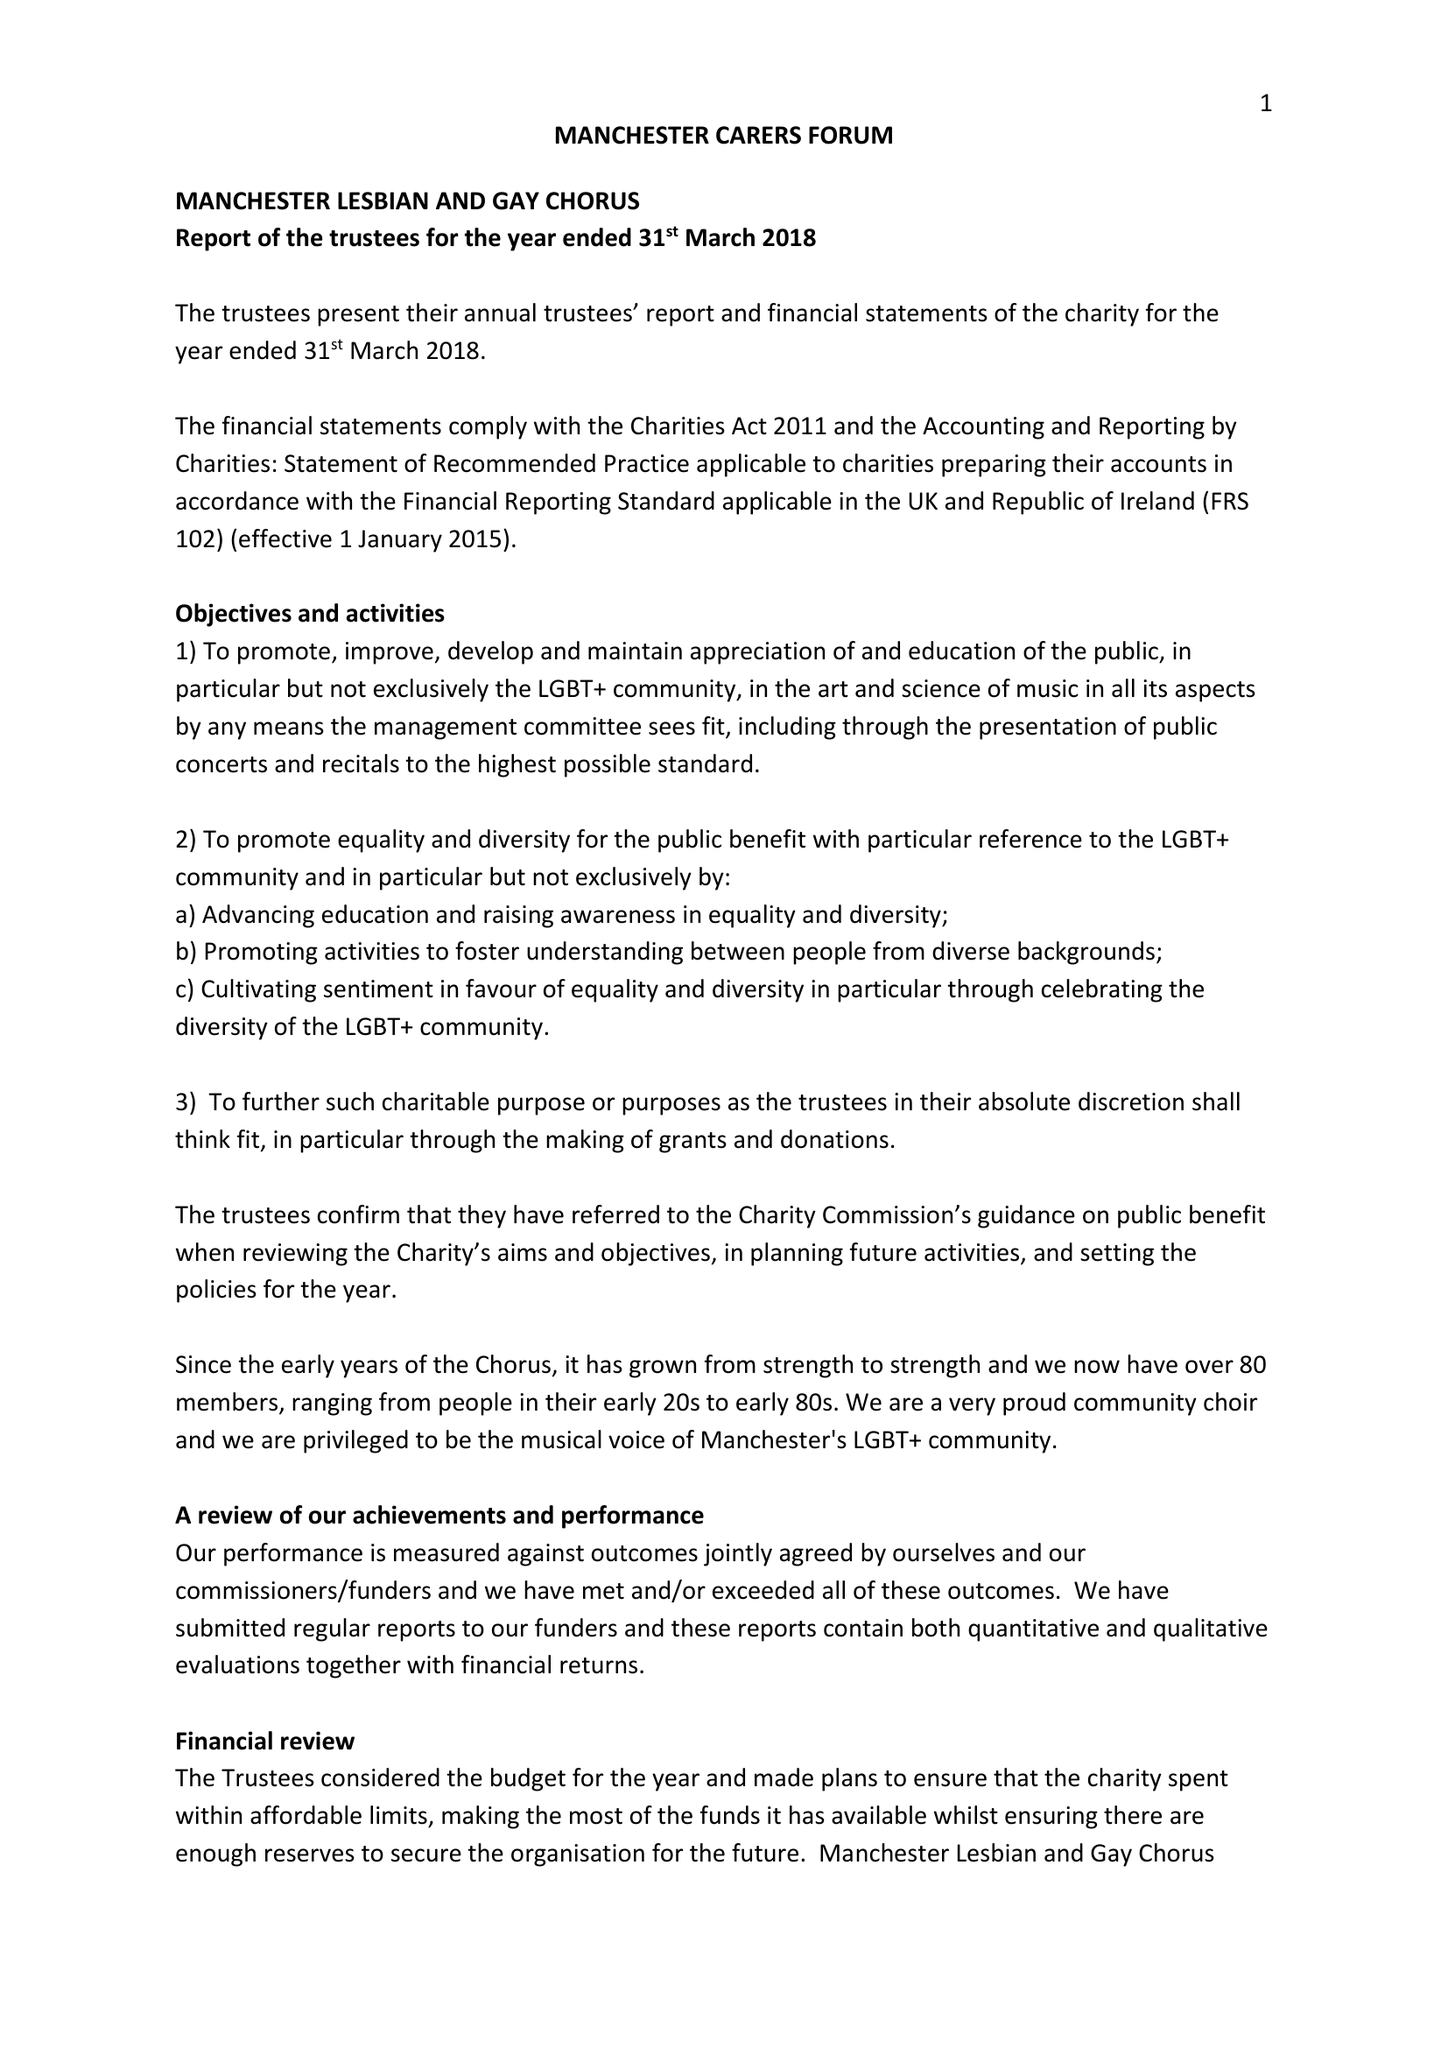What is the value for the address__postcode?
Answer the question using a single word or phrase. CH2 3JD 